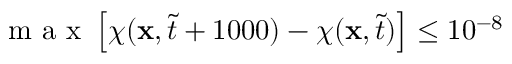Convert formula to latex. <formula><loc_0><loc_0><loc_500><loc_500>m a x \left [ \chi ( x , \tilde { t } + 1 0 0 0 ) - \chi ( x , \tilde { t } ) \right ] \leq 1 0 ^ { - 8 }</formula> 